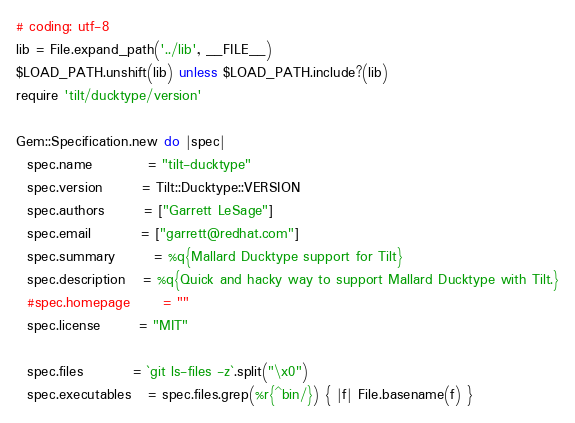<code> <loc_0><loc_0><loc_500><loc_500><_Ruby_># coding: utf-8
lib = File.expand_path('../lib', __FILE__)
$LOAD_PATH.unshift(lib) unless $LOAD_PATH.include?(lib)
require 'tilt/ducktype/version'

Gem::Specification.new do |spec|
  spec.name          = "tilt-ducktype"
  spec.version       = Tilt::Ducktype::VERSION
  spec.authors       = ["Garrett LeSage"]
  spec.email         = ["garrett@redhat.com"]
  spec.summary       = %q{Mallard Ducktype support for Tilt}
  spec.description   = %q{Quick and hacky way to support Mallard Ducktype with Tilt.}
  #spec.homepage      = ""
  spec.license       = "MIT"

  spec.files         = `git ls-files -z`.split("\x0")
  spec.executables   = spec.files.grep(%r{^bin/}) { |f| File.basename(f) }</code> 